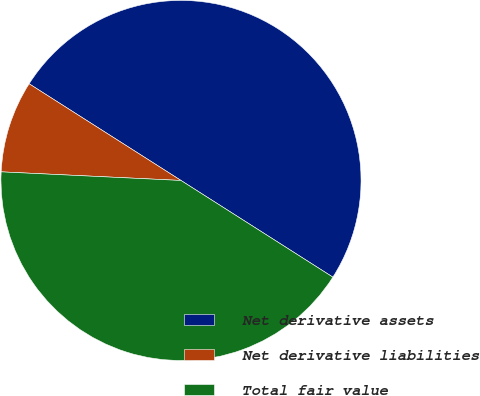Convert chart to OTSL. <chart><loc_0><loc_0><loc_500><loc_500><pie_chart><fcel>Net derivative assets<fcel>Net derivative liabilities<fcel>Total fair value<nl><fcel>50.0%<fcel>8.26%<fcel>41.74%<nl></chart> 